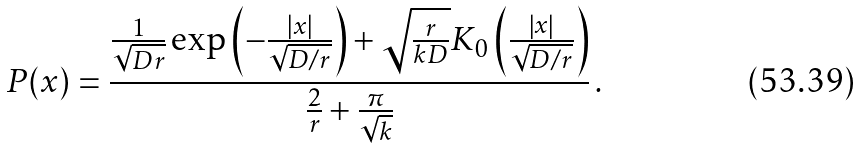Convert formula to latex. <formula><loc_0><loc_0><loc_500><loc_500>P ( x ) = \frac { \frac { 1 } { \sqrt { D r } } \exp \left ( - \frac { | x | } { \sqrt { D / r } } \right ) + \sqrt { \frac { r } { k D } } K _ { 0 } \left ( \frac { \left | x \right | } { \sqrt { D / r } } \right ) } { \frac { 2 } { r } + \frac { \pi } { \sqrt { k } } } \, .</formula> 